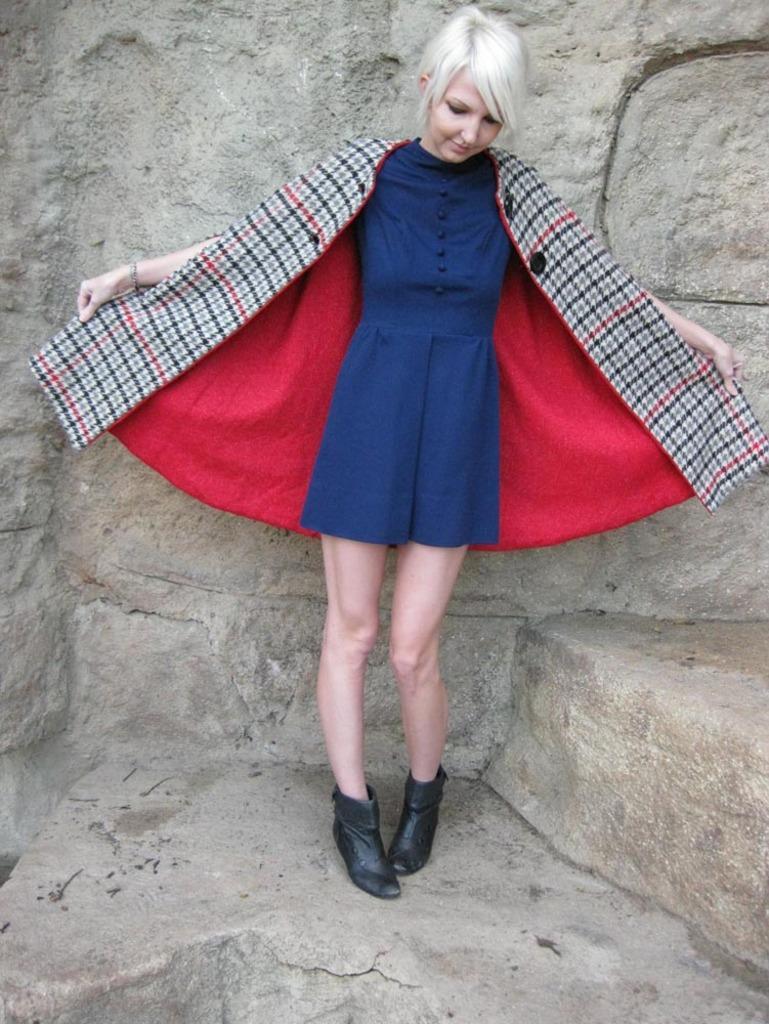Can you describe this image briefly? In the picture I can see a woman is standing and holding the dress in hands. The woman is wearing blue color dress and black color shoes. In the background I can see a wall. 